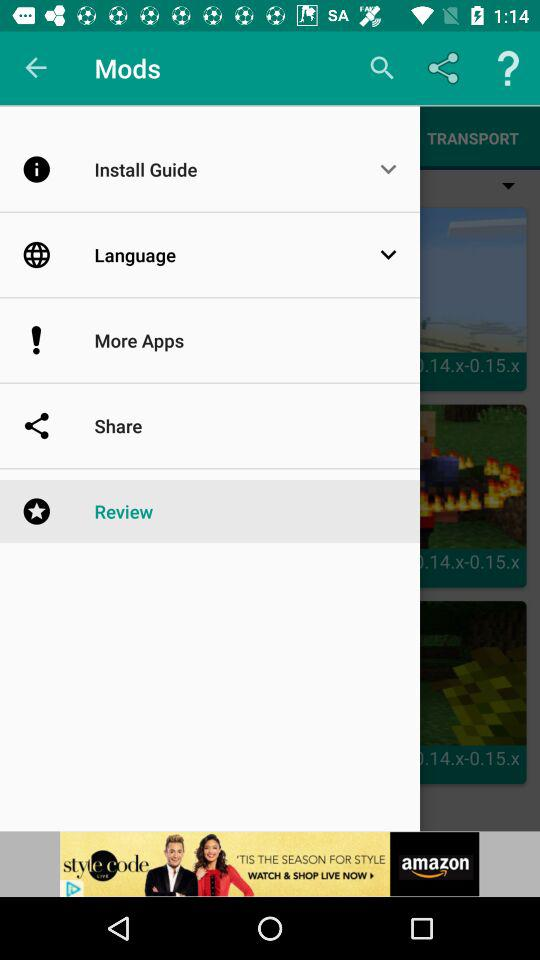How many items have a screenshot?
Answer the question using a single word or phrase. 3 